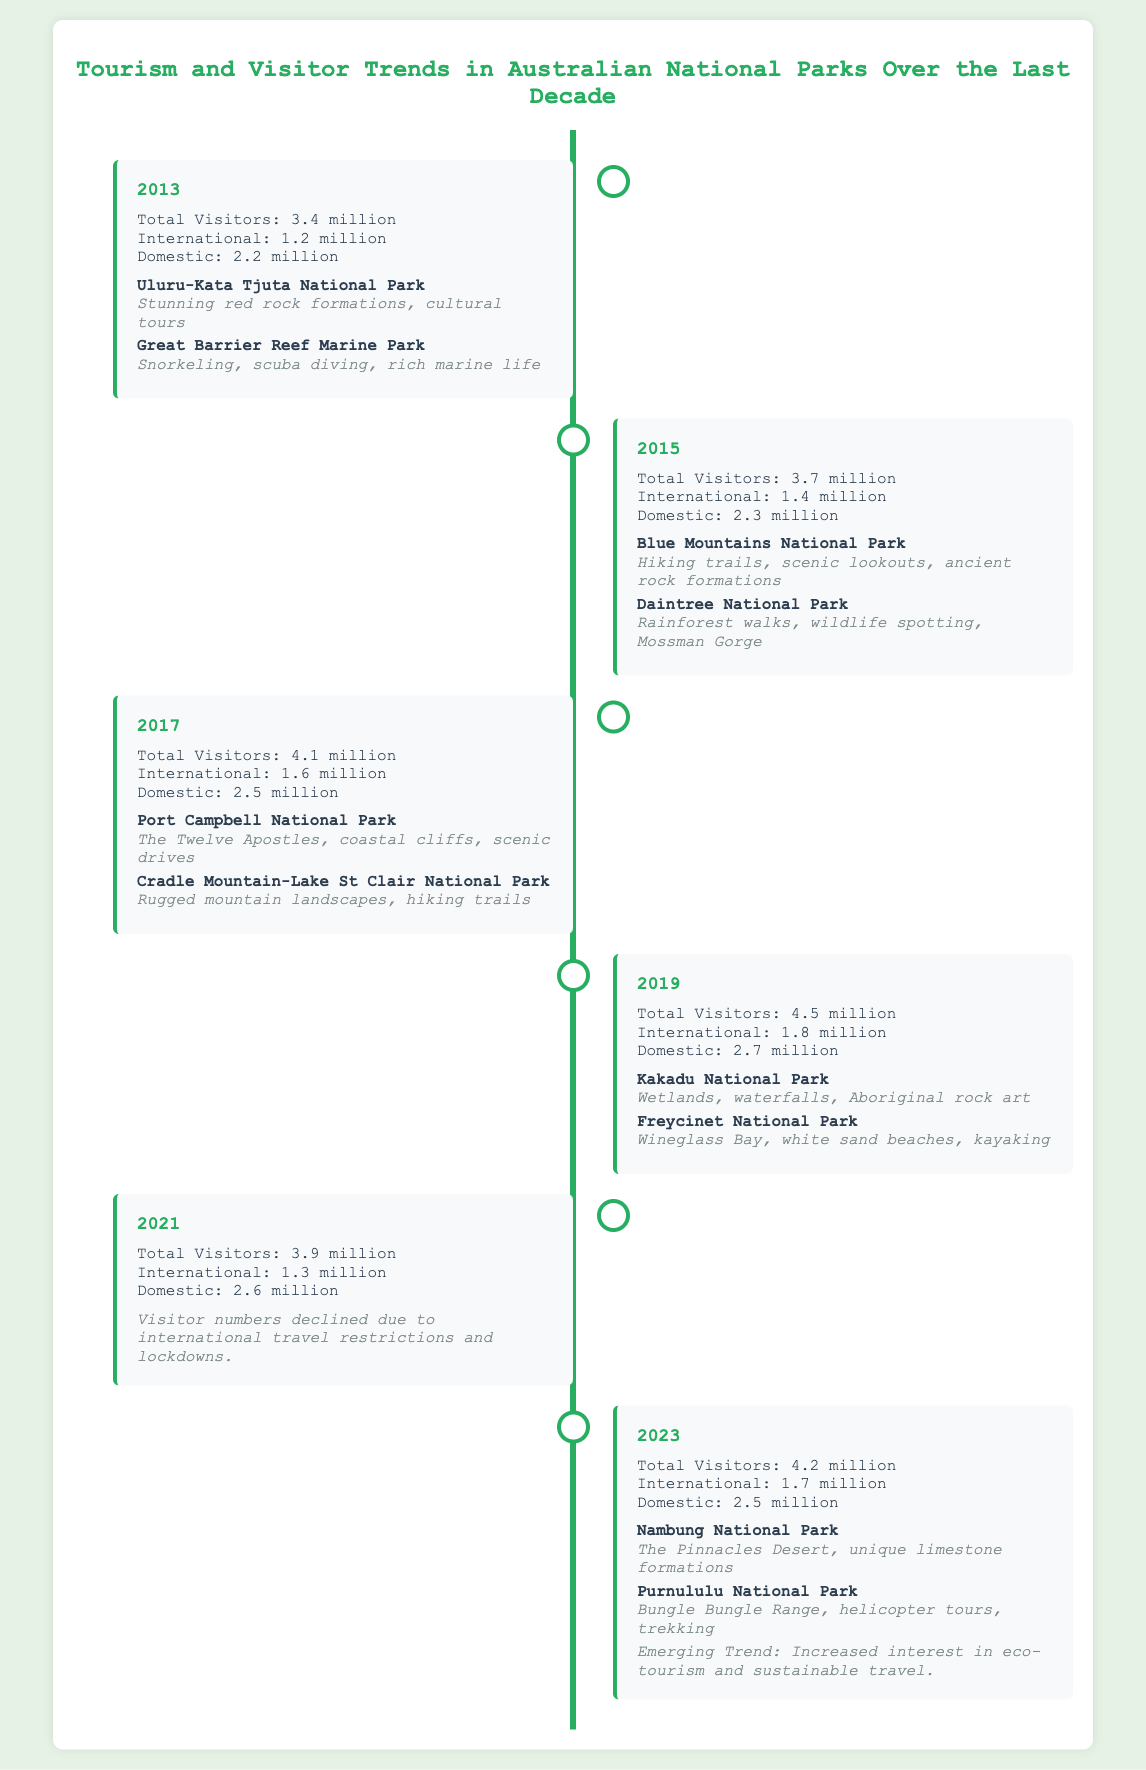What was the total number of visitors in 2013? The total number of visitors for the year 2013 is listed in the visitor statistics section.
Answer: 3.4 million Which national park had the highest visitor numbers in 2019? The park with the highest visitor numbers in 2019 can be inferred from the trends shown in the document.
Answer: Kakadu National Park What was the total number of domestic visitors in 2021? The document specifies the domestic visitor count for the year 2021 directly in the visitor statistics.
Answer: 2.6 million What trend emerged in 2023? The document highlights the emerging trend noted in the 2023 entry.
Answer: Increased interest in eco-tourism and sustainable travel How many international visitors were recorded in 2017? The number of international visitors for 2017 is provided in the visitor statistics section.
Answer: 1.6 million Which year saw a decline in visitor numbers? The document notes a decline in visitor numbers, which can be pinpointed in the section for a specific year.
Answer: 2021 What are two attractions mentioned for Uluru-Kata Tjuta National Park in 2013? The attractions listed under Uluru-Kata Tjuta National Park in 2013 can be found in the attractions section.
Answer: Stunning red rock formations, cultural tours What year had the total number of visitors at 4.1 million? The specific entry with the total number of visitors listed can be identified.
Answer: 2017 